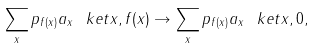Convert formula to latex. <formula><loc_0><loc_0><loc_500><loc_500>\sum _ { x } p _ { f ( x ) } a _ { x } \ k e t { x , f ( x ) } \rightarrow \sum _ { x } p _ { f ( x ) } a _ { x } \ k e t { x , 0 } ,</formula> 